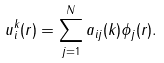<formula> <loc_0><loc_0><loc_500><loc_500>u _ { i } ^ { k } ( { r } ) = \sum _ { j = 1 } ^ { N } a _ { i j } ( { k } ) \phi _ { j } ( { r } ) .</formula> 